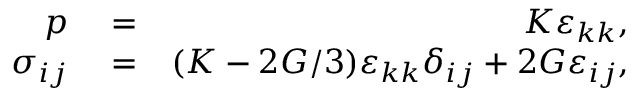Convert formula to latex. <formula><loc_0><loc_0><loc_500><loc_500>\begin{array} { r l r } { p } & = } & { K \varepsilon _ { k k } , } \\ { \sigma _ { i j } } & = } & { ( K - 2 G / 3 ) \varepsilon _ { k k } \delta _ { i j } + 2 G \varepsilon _ { i j } , } \end{array}</formula> 